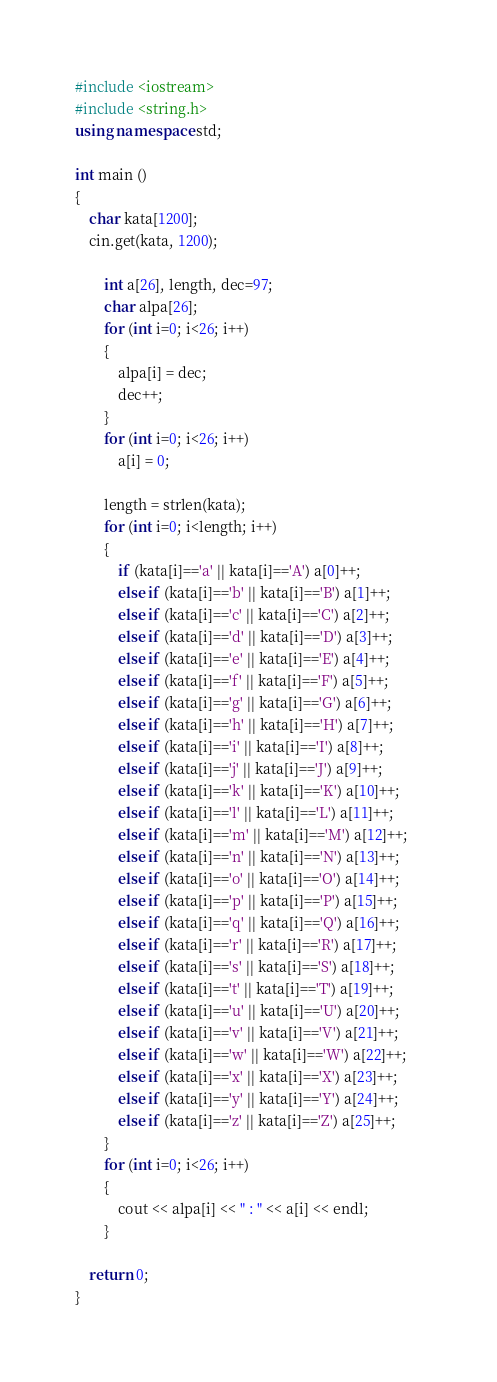Convert code to text. <code><loc_0><loc_0><loc_500><loc_500><_C++_>#include <iostream>
#include <string.h>
using namespace std;

int main ()
{
	char kata[1200];
	cin.get(kata, 1200);
	
		int a[26], length, dec=97;
		char alpa[26];
		for (int i=0; i<26; i++)
		{
			alpa[i] = dec;
			dec++;
		}
		for (int i=0; i<26; i++)
			a[i] = 0;
		
		length = strlen(kata);
		for (int i=0; i<length; i++)
		{
			if (kata[i]=='a' || kata[i]=='A') a[0]++;				 
			else if (kata[i]=='b' || kata[i]=='B') a[1]++;
			else if (kata[i]=='c' || kata[i]=='C') a[2]++;
			else if (kata[i]=='d' || kata[i]=='D') a[3]++;
			else if (kata[i]=='e' || kata[i]=='E') a[4]++;
			else if (kata[i]=='f' || kata[i]=='F') a[5]++;
			else if (kata[i]=='g' || kata[i]=='G') a[6]++;
			else if (kata[i]=='h' || kata[i]=='H') a[7]++;
			else if (kata[i]=='i' || kata[i]=='I') a[8]++;
			else if (kata[i]=='j' || kata[i]=='J') a[9]++;
			else if (kata[i]=='k' || kata[i]=='K') a[10]++;
			else if (kata[i]=='l' || kata[i]=='L') a[11]++;
			else if (kata[i]=='m' || kata[i]=='M') a[12]++;
			else if (kata[i]=='n' || kata[i]=='N') a[13]++;
			else if (kata[i]=='o' || kata[i]=='O') a[14]++;
			else if (kata[i]=='p' || kata[i]=='P') a[15]++;
			else if (kata[i]=='q' || kata[i]=='Q') a[16]++;
			else if (kata[i]=='r' || kata[i]=='R') a[17]++;
			else if (kata[i]=='s' || kata[i]=='S') a[18]++;
			else if (kata[i]=='t' || kata[i]=='T') a[19]++;
			else if (kata[i]=='u' || kata[i]=='U') a[20]++;
			else if (kata[i]=='v' || kata[i]=='V') a[21]++;
			else if (kata[i]=='w' || kata[i]=='W') a[22]++;
			else if (kata[i]=='x' || kata[i]=='X') a[23]++;
			else if (kata[i]=='y' || kata[i]=='Y') a[24]++;
			else if (kata[i]=='z' || kata[i]=='Z') a[25]++;	
		}
		for (int i=0; i<26; i++)
		{
			cout << alpa[i] << " : " << a[i] << endl;
		}
	
	return 0;
}</code> 